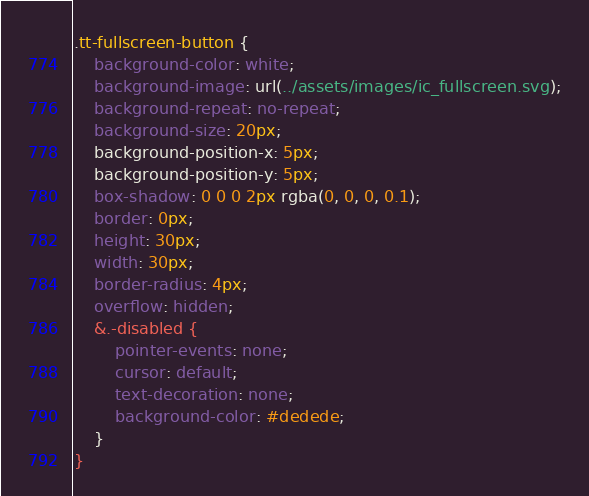<code> <loc_0><loc_0><loc_500><loc_500><_CSS_>.tt-fullscreen-button {
    background-color: white;
    background-image: url(../assets/images/ic_fullscreen.svg);
    background-repeat: no-repeat;
    background-size: 20px;
    background-position-x: 5px;
    background-position-y: 5px;
    box-shadow: 0 0 0 2px rgba(0, 0, 0, 0.1);
    border: 0px;
    height: 30px;
    width: 30px;
    border-radius: 4px;
    overflow: hidden;
    &.-disabled {
        pointer-events: none;
        cursor: default;
        text-decoration: none;
        background-color: #dedede;
    }
}</code> 